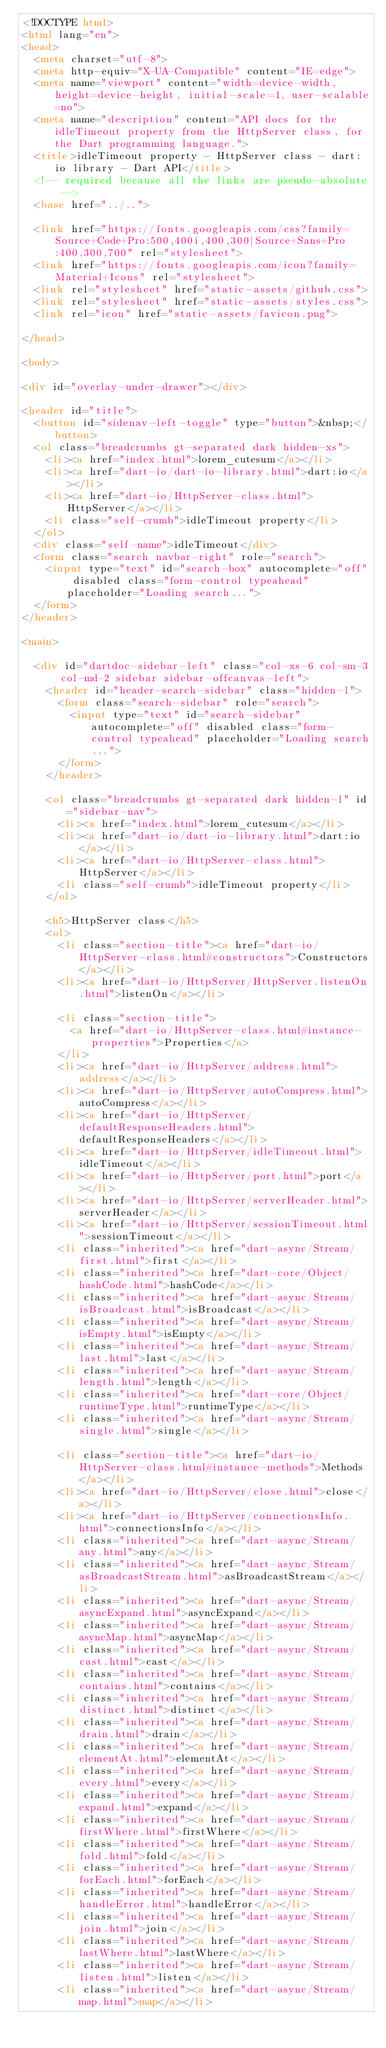<code> <loc_0><loc_0><loc_500><loc_500><_HTML_><!DOCTYPE html>
<html lang="en">
<head>
  <meta charset="utf-8">
  <meta http-equiv="X-UA-Compatible" content="IE=edge">
  <meta name="viewport" content="width=device-width, height=device-height, initial-scale=1, user-scalable=no">
  <meta name="description" content="API docs for the idleTimeout property from the HttpServer class, for the Dart programming language.">
  <title>idleTimeout property - HttpServer class - dart:io library - Dart API</title>
  <!-- required because all the links are pseudo-absolute -->
  <base href="../..">

  <link href="https://fonts.googleapis.com/css?family=Source+Code+Pro:500,400i,400,300|Source+Sans+Pro:400,300,700" rel="stylesheet">
  <link href="https://fonts.googleapis.com/icon?family=Material+Icons" rel="stylesheet">
  <link rel="stylesheet" href="static-assets/github.css">
  <link rel="stylesheet" href="static-assets/styles.css">
  <link rel="icon" href="static-assets/favicon.png">
  
</head>

<body>

<div id="overlay-under-drawer"></div>

<header id="title">
  <button id="sidenav-left-toggle" type="button">&nbsp;</button>
  <ol class="breadcrumbs gt-separated dark hidden-xs">
    <li><a href="index.html">lorem_cutesum</a></li>
    <li><a href="dart-io/dart-io-library.html">dart:io</a></li>
    <li><a href="dart-io/HttpServer-class.html">HttpServer</a></li>
    <li class="self-crumb">idleTimeout property</li>
  </ol>
  <div class="self-name">idleTimeout</div>
  <form class="search navbar-right" role="search">
    <input type="text" id="search-box" autocomplete="off" disabled class="form-control typeahead" placeholder="Loading search...">
  </form>
</header>

<main>

  <div id="dartdoc-sidebar-left" class="col-xs-6 col-sm-3 col-md-2 sidebar sidebar-offcanvas-left">
    <header id="header-search-sidebar" class="hidden-l">
      <form class="search-sidebar" role="search">
        <input type="text" id="search-sidebar" autocomplete="off" disabled class="form-control typeahead" placeholder="Loading search...">
      </form>
    </header>
    
    <ol class="breadcrumbs gt-separated dark hidden-l" id="sidebar-nav">
      <li><a href="index.html">lorem_cutesum</a></li>
      <li><a href="dart-io/dart-io-library.html">dart:io</a></li>
      <li><a href="dart-io/HttpServer-class.html">HttpServer</a></li>
      <li class="self-crumb">idleTimeout property</li>
    </ol>
    
    <h5>HttpServer class</h5>
    <ol>
      <li class="section-title"><a href="dart-io/HttpServer-class.html#constructors">Constructors</a></li>
      <li><a href="dart-io/HttpServer/HttpServer.listenOn.html">listenOn</a></li>
    
      <li class="section-title">
        <a href="dart-io/HttpServer-class.html#instance-properties">Properties</a>
      </li>
      <li><a href="dart-io/HttpServer/address.html">address</a></li>
      <li><a href="dart-io/HttpServer/autoCompress.html">autoCompress</a></li>
      <li><a href="dart-io/HttpServer/defaultResponseHeaders.html">defaultResponseHeaders</a></li>
      <li><a href="dart-io/HttpServer/idleTimeout.html">idleTimeout</a></li>
      <li><a href="dart-io/HttpServer/port.html">port</a></li>
      <li><a href="dart-io/HttpServer/serverHeader.html">serverHeader</a></li>
      <li><a href="dart-io/HttpServer/sessionTimeout.html">sessionTimeout</a></li>
      <li class="inherited"><a href="dart-async/Stream/first.html">first</a></li>
      <li class="inherited"><a href="dart-core/Object/hashCode.html">hashCode</a></li>
      <li class="inherited"><a href="dart-async/Stream/isBroadcast.html">isBroadcast</a></li>
      <li class="inherited"><a href="dart-async/Stream/isEmpty.html">isEmpty</a></li>
      <li class="inherited"><a href="dart-async/Stream/last.html">last</a></li>
      <li class="inherited"><a href="dart-async/Stream/length.html">length</a></li>
      <li class="inherited"><a href="dart-core/Object/runtimeType.html">runtimeType</a></li>
      <li class="inherited"><a href="dart-async/Stream/single.html">single</a></li>
    
      <li class="section-title"><a href="dart-io/HttpServer-class.html#instance-methods">Methods</a></li>
      <li><a href="dart-io/HttpServer/close.html">close</a></li>
      <li><a href="dart-io/HttpServer/connectionsInfo.html">connectionsInfo</a></li>
      <li class="inherited"><a href="dart-async/Stream/any.html">any</a></li>
      <li class="inherited"><a href="dart-async/Stream/asBroadcastStream.html">asBroadcastStream</a></li>
      <li class="inherited"><a href="dart-async/Stream/asyncExpand.html">asyncExpand</a></li>
      <li class="inherited"><a href="dart-async/Stream/asyncMap.html">asyncMap</a></li>
      <li class="inherited"><a href="dart-async/Stream/cast.html">cast</a></li>
      <li class="inherited"><a href="dart-async/Stream/contains.html">contains</a></li>
      <li class="inherited"><a href="dart-async/Stream/distinct.html">distinct</a></li>
      <li class="inherited"><a href="dart-async/Stream/drain.html">drain</a></li>
      <li class="inherited"><a href="dart-async/Stream/elementAt.html">elementAt</a></li>
      <li class="inherited"><a href="dart-async/Stream/every.html">every</a></li>
      <li class="inherited"><a href="dart-async/Stream/expand.html">expand</a></li>
      <li class="inherited"><a href="dart-async/Stream/firstWhere.html">firstWhere</a></li>
      <li class="inherited"><a href="dart-async/Stream/fold.html">fold</a></li>
      <li class="inherited"><a href="dart-async/Stream/forEach.html">forEach</a></li>
      <li class="inherited"><a href="dart-async/Stream/handleError.html">handleError</a></li>
      <li class="inherited"><a href="dart-async/Stream/join.html">join</a></li>
      <li class="inherited"><a href="dart-async/Stream/lastWhere.html">lastWhere</a></li>
      <li class="inherited"><a href="dart-async/Stream/listen.html">listen</a></li>
      <li class="inherited"><a href="dart-async/Stream/map.html">map</a></li></code> 